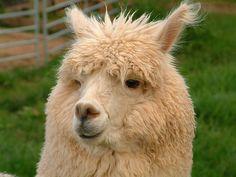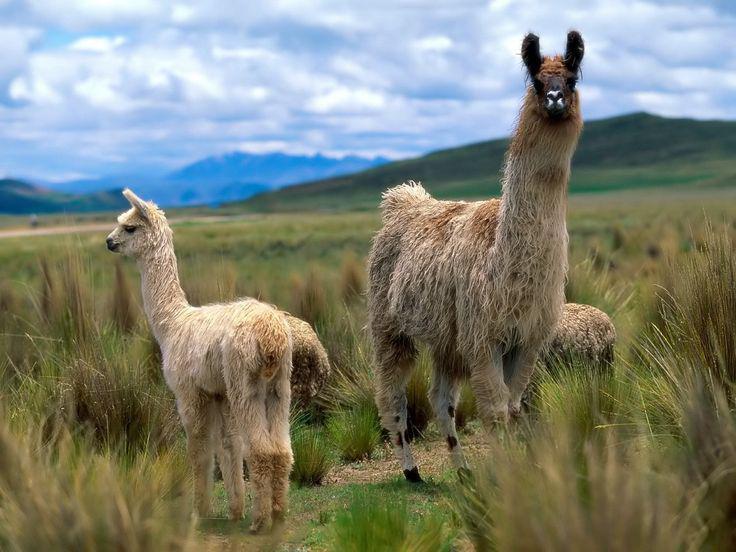The first image is the image on the left, the second image is the image on the right. For the images displayed, is the sentence "The left and right image contains three llamas." factually correct? Answer yes or no. No. 